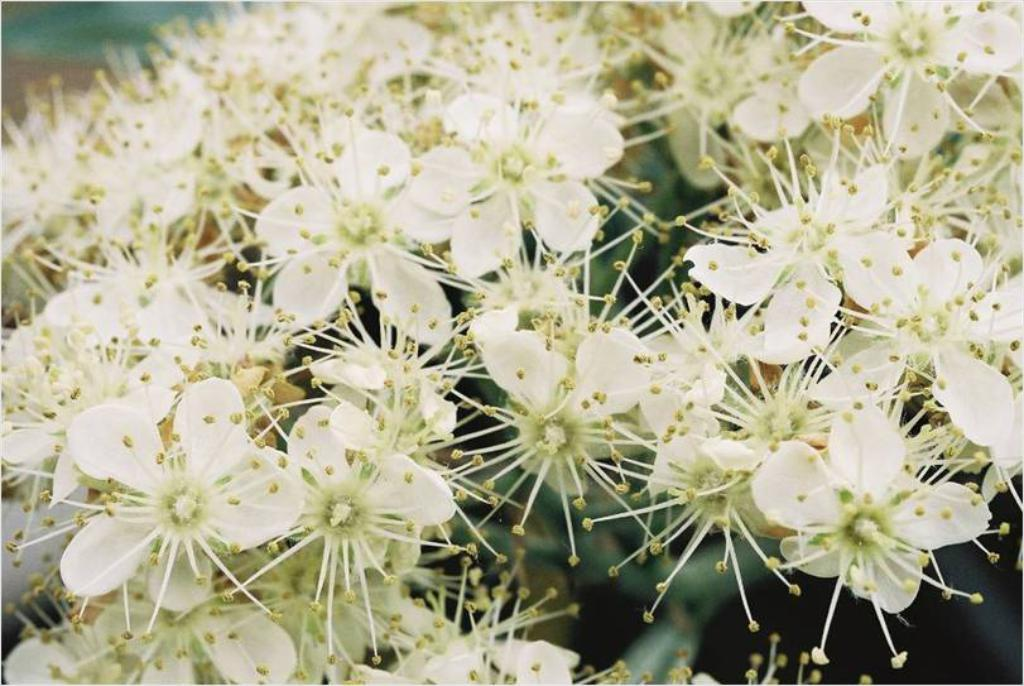What type of flowers can be seen in the image? There are white color flowers in the image. Is the queen holding a frame with salt in the image? There is no queen, frame, or salt present in the image; it only features white color flowers. 